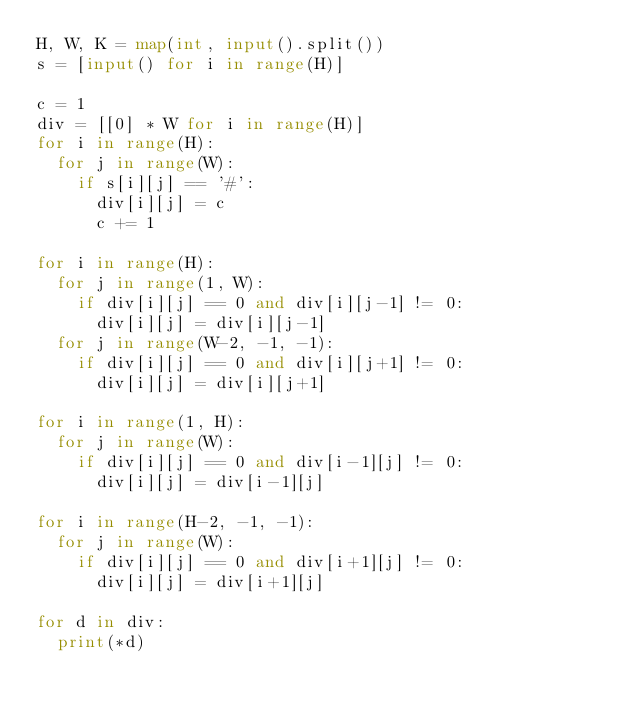<code> <loc_0><loc_0><loc_500><loc_500><_Python_>H, W, K = map(int, input().split())
s = [input() for i in range(H)]

c = 1
div = [[0] * W for i in range(H)]
for i in range(H):
  for j in range(W):
    if s[i][j] == '#':
      div[i][j] = c
      c += 1

for i in range(H):
  for j in range(1, W):
    if div[i][j] == 0 and div[i][j-1] != 0:
      div[i][j] = div[i][j-1]
  for j in range(W-2, -1, -1):
    if div[i][j] == 0 and div[i][j+1] != 0:
      div[i][j] = div[i][j+1]

for i in range(1, H):
  for j in range(W):
    if div[i][j] == 0 and div[i-1][j] != 0:
      div[i][j] = div[i-1][j]

for i in range(H-2, -1, -1):
  for j in range(W):
    if div[i][j] == 0 and div[i+1][j] != 0:
      div[i][j] = div[i+1][j]

for d in div:
  print(*d)</code> 